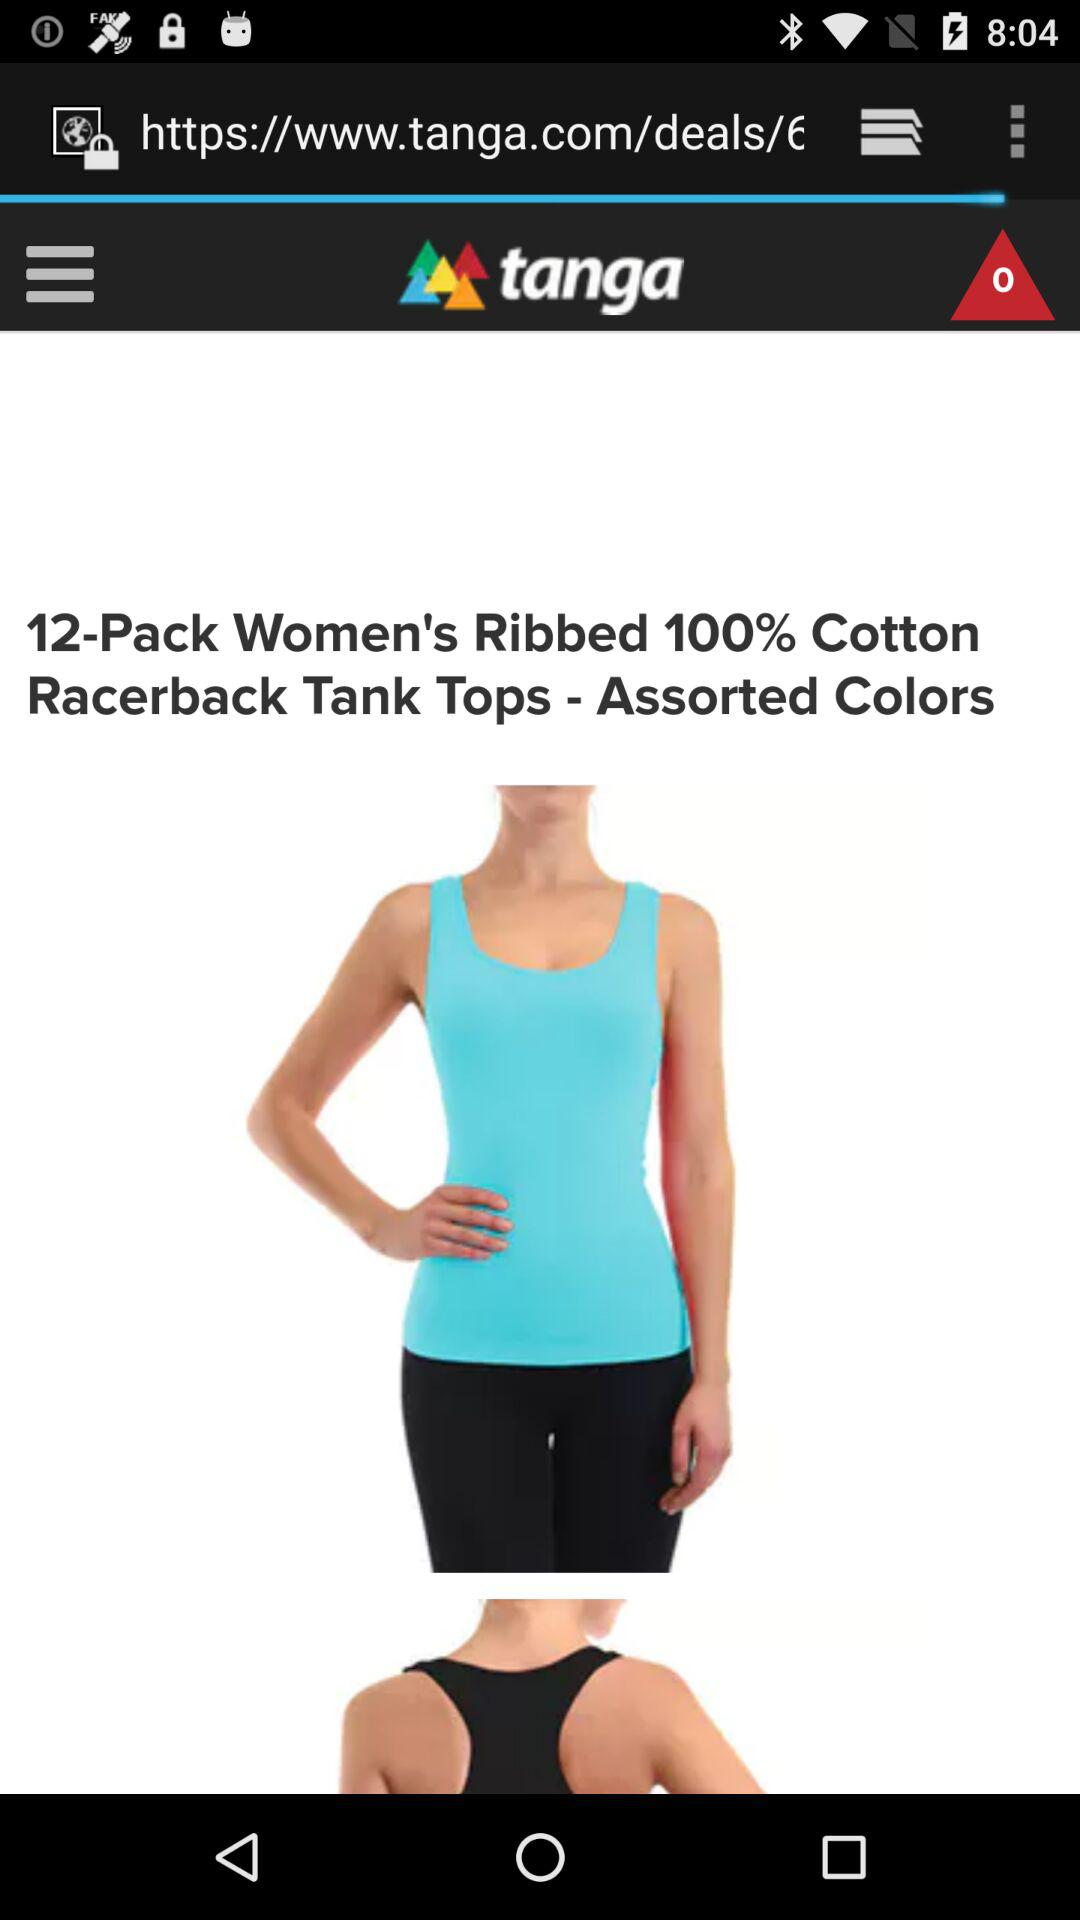What is the application's name? The application's name is "tanga". 